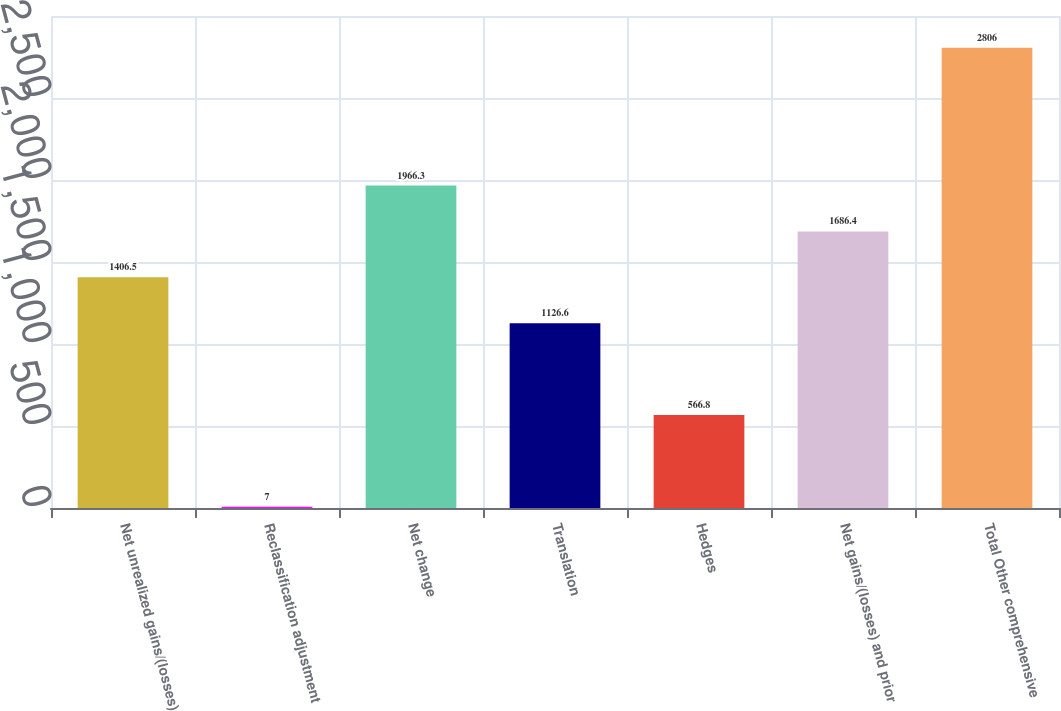Convert chart to OTSL. <chart><loc_0><loc_0><loc_500><loc_500><bar_chart><fcel>Net unrealized gains/(losses)<fcel>Reclassification adjustment<fcel>Net change<fcel>Translation<fcel>Hedges<fcel>Net gains/(losses) and prior<fcel>Total Other comprehensive<nl><fcel>1406.5<fcel>7<fcel>1966.3<fcel>1126.6<fcel>566.8<fcel>1686.4<fcel>2806<nl></chart> 